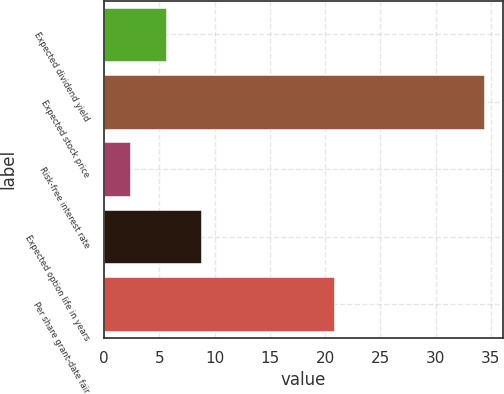Convert chart to OTSL. <chart><loc_0><loc_0><loc_500><loc_500><bar_chart><fcel>Expected dividend yield<fcel>Expected stock price<fcel>Risk-free interest rate<fcel>Expected option life in years<fcel>Per share grant-date fair<nl><fcel>5.6<fcel>34.4<fcel>2.4<fcel>8.8<fcel>20.85<nl></chart> 